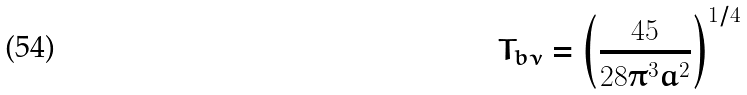<formula> <loc_0><loc_0><loc_500><loc_500>T _ { b \nu } = \left ( \frac { 4 5 } { 2 8 \pi ^ { 3 } a ^ { 2 } } \right ) ^ { 1 / 4 }</formula> 